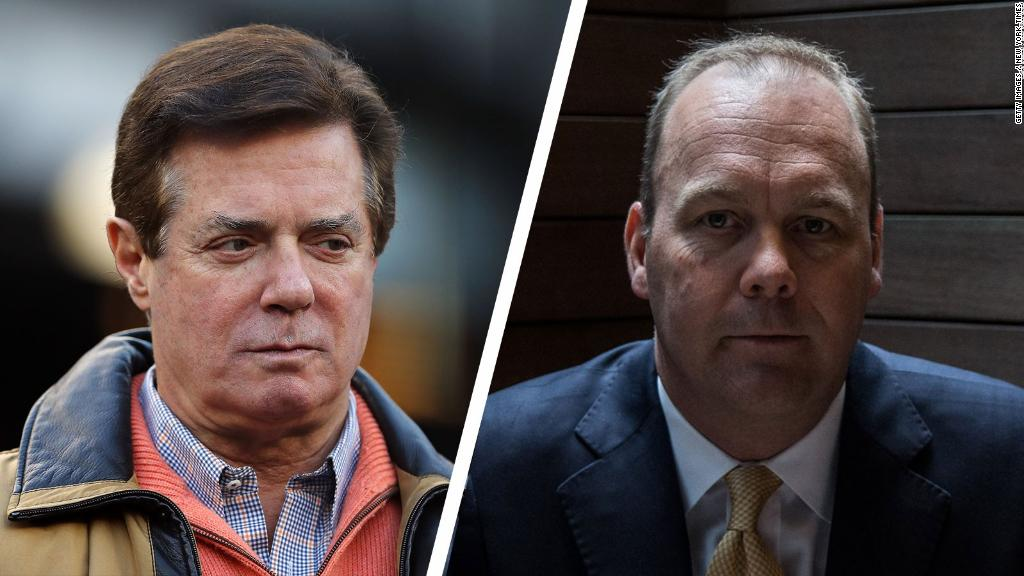If these individuals were characters in a fantasy novel, what magical abilities might they have? In a fantasy novel, John might possess the ability to manipulate technology with his mind, creating magical devices and intricate networks that can communicate across realms. His attire, a blend of casual and professional, could symbolize his grounded nature and his innovative spirit that transcends traditional boundaries.

David, in contrast, might have the power to read minds and see through disguises, making him a formidable opponent in any political intrigue. His formal suit and tie could be enchanted clothing that grant him enhanced abilities, such as heightened perception and incredible agility. Together, they would navigate a kingdom fraught with deception and mystical challenges, their abilities complementing each other as they seek to restore balance to their world. 